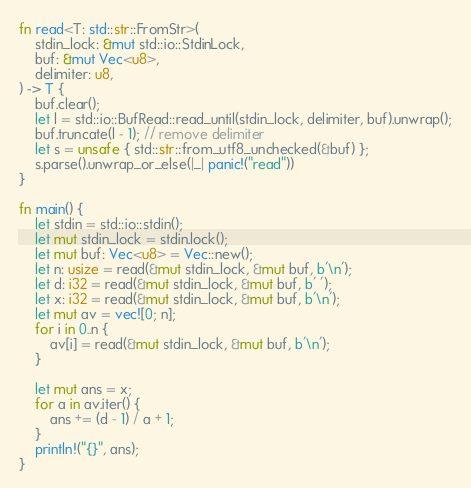Convert code to text. <code><loc_0><loc_0><loc_500><loc_500><_Rust_>fn read<T: std::str::FromStr>(
    stdin_lock: &mut std::io::StdinLock,
    buf: &mut Vec<u8>,
    delimiter: u8,
) -> T {
    buf.clear();
    let l = std::io::BufRead::read_until(stdin_lock, delimiter, buf).unwrap();
    buf.truncate(l - 1); // remove delimiter
    let s = unsafe { std::str::from_utf8_unchecked(&buf) };
    s.parse().unwrap_or_else(|_| panic!("read"))
}

fn main() {
    let stdin = std::io::stdin();
    let mut stdin_lock = stdin.lock();
    let mut buf: Vec<u8> = Vec::new();
    let n: usize = read(&mut stdin_lock, &mut buf, b'\n');
    let d: i32 = read(&mut stdin_lock, &mut buf, b' ');
    let x: i32 = read(&mut stdin_lock, &mut buf, b'\n');
    let mut av = vec![0; n];
    for i in 0..n {
        av[i] = read(&mut stdin_lock, &mut buf, b'\n');
    }

    let mut ans = x;
    for a in av.iter() {
        ans += (d - 1) / a + 1;
    }
    println!("{}", ans);
}
</code> 